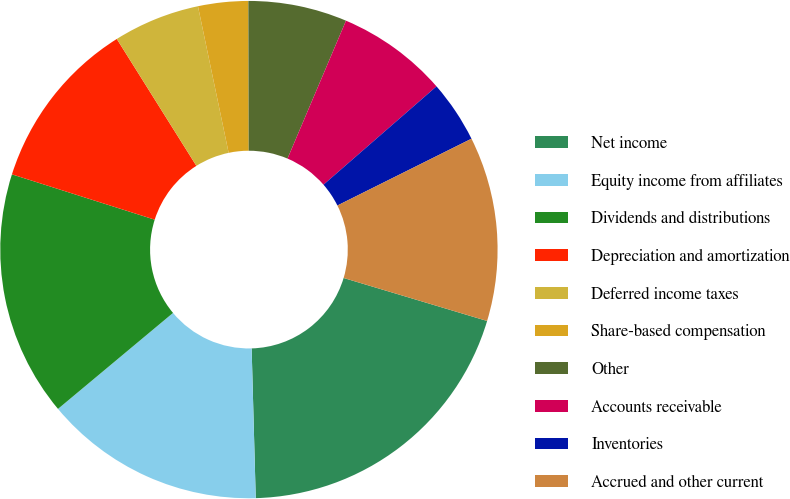<chart> <loc_0><loc_0><loc_500><loc_500><pie_chart><fcel>Net income<fcel>Equity income from affiliates<fcel>Dividends and distributions<fcel>Depreciation and amortization<fcel>Deferred income taxes<fcel>Share-based compensation<fcel>Other<fcel>Accounts receivable<fcel>Inventories<fcel>Accrued and other current<nl><fcel>19.93%<fcel>14.37%<fcel>15.96%<fcel>11.19%<fcel>5.63%<fcel>3.25%<fcel>6.42%<fcel>7.22%<fcel>4.04%<fcel>11.99%<nl></chart> 